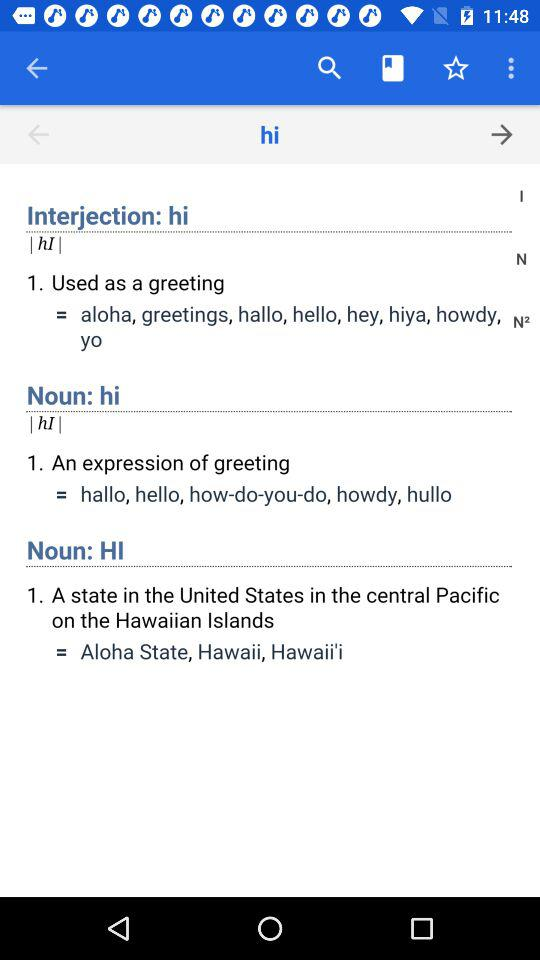What is the meaning of hi as noun? What is the meaning of "hi" as a noun? The meaning of "hi" as a noun is "An expression of greeting". 